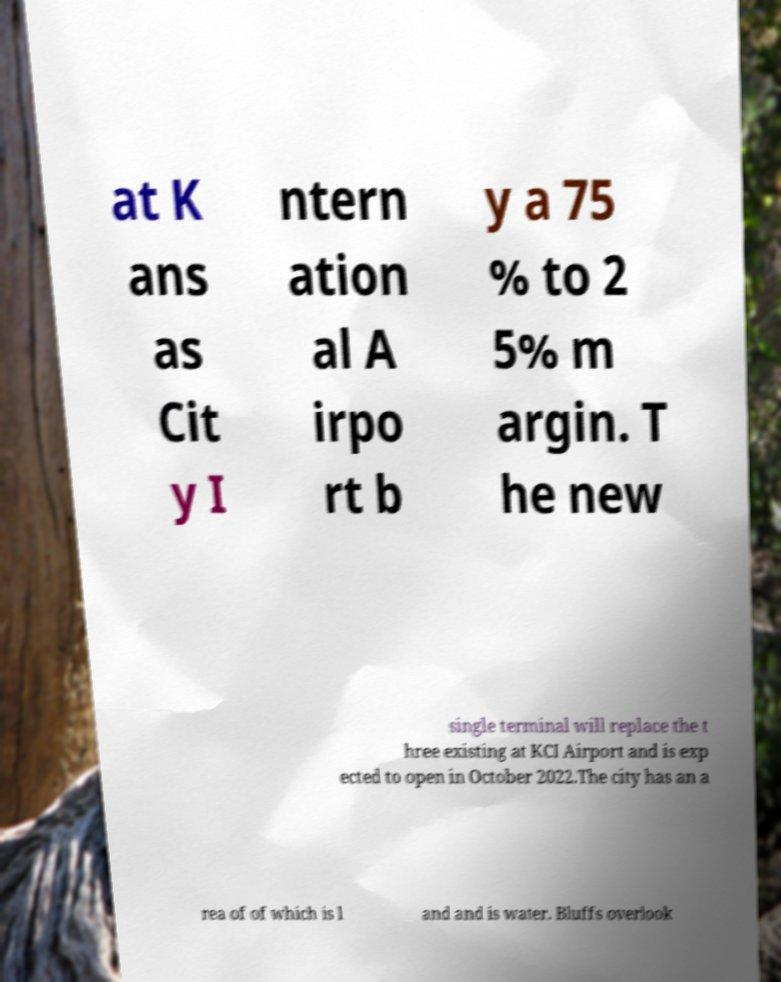Please read and relay the text visible in this image. What does it say? at K ans as Cit y I ntern ation al A irpo rt b y a 75 % to 2 5% m argin. T he new single terminal will replace the t hree existing at KCI Airport and is exp ected to open in October 2022.The city has an a rea of of which is l and and is water. Bluffs overlook 